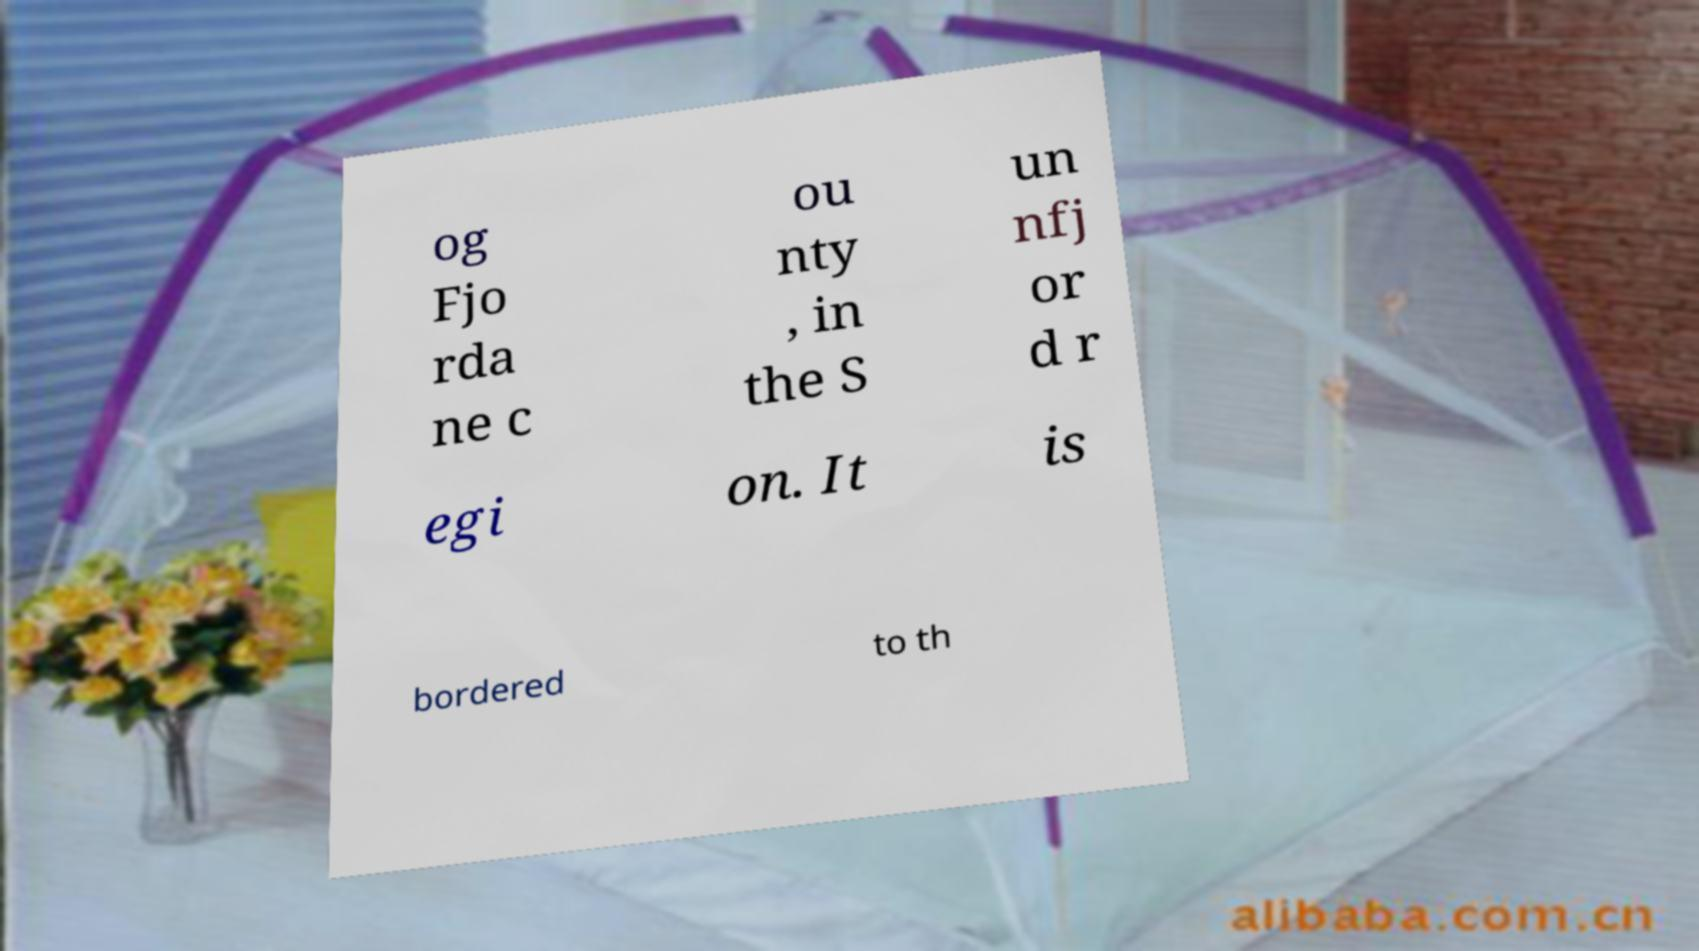What messages or text are displayed in this image? I need them in a readable, typed format. og Fjo rda ne c ou nty , in the S un nfj or d r egi on. It is bordered to th 